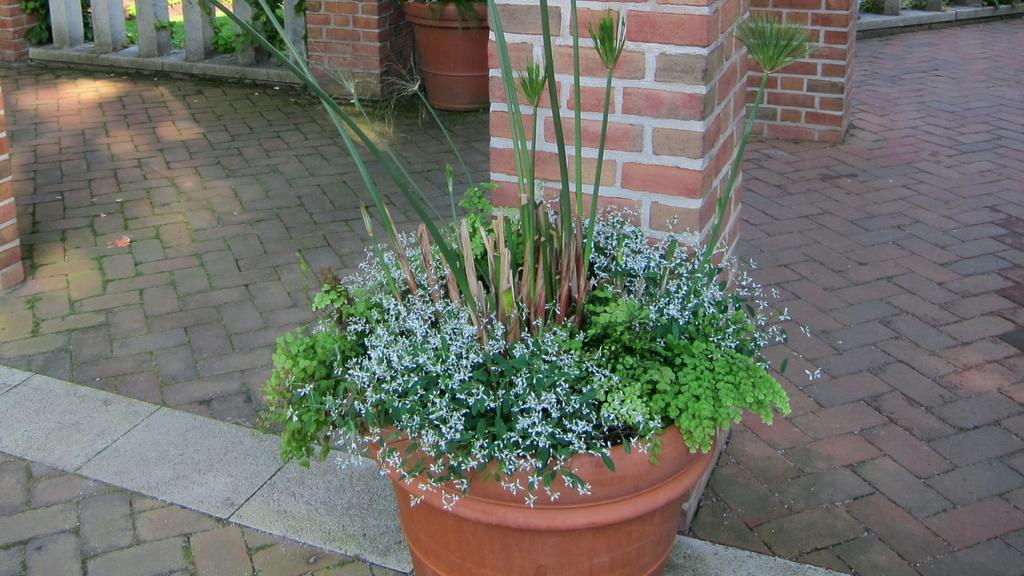What color is the flower pot in the image? The flower pot in the image is brown. What color are the plants in the image? The plants in the image are green. What architectural features can be seen in the image? There are pillars in the image. What surface can be seen beneath the plants and flower pot? There is a floor in the image. Can you tell me how many experts are present in the image? There are no experts present in the image; it features a brown flower pot, green plants, pillars, and a floor. Is there any water visible in the image? There is no water visible in the image. 